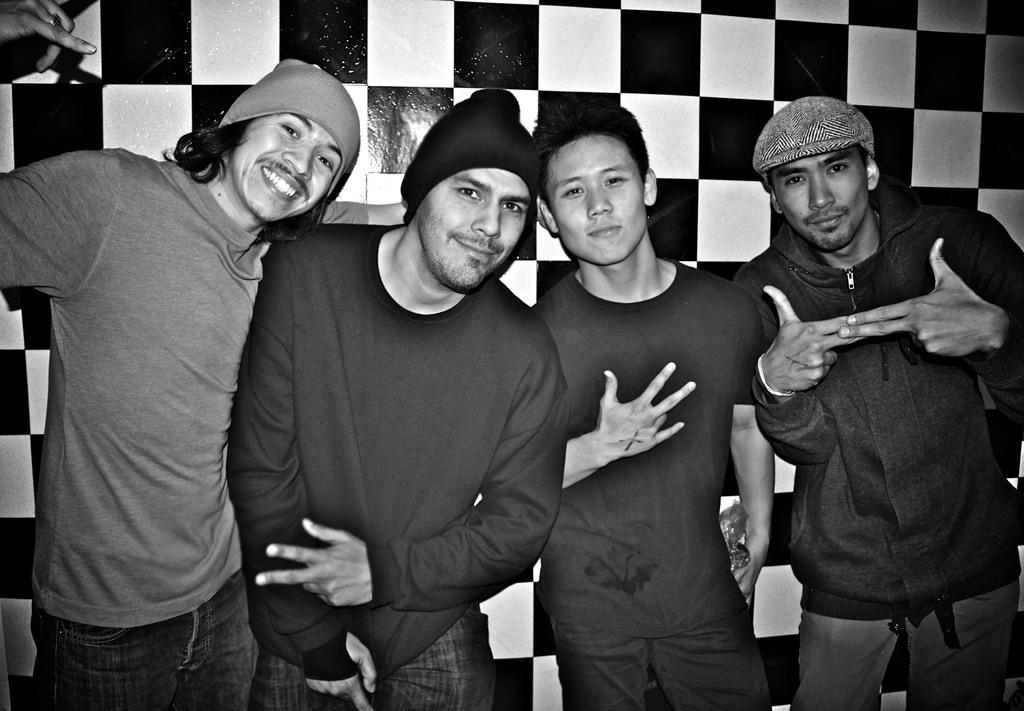Please provide a concise description of this image. In this image we can see few people standing near the wall and a person is holding an object. 